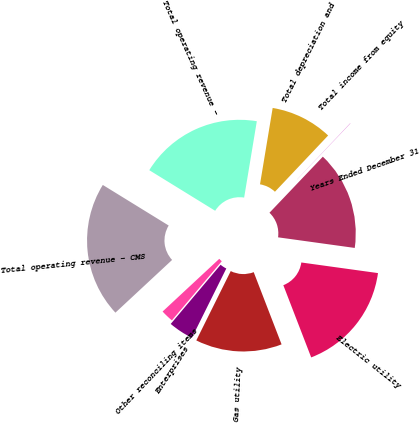Convert chart to OTSL. <chart><loc_0><loc_0><loc_500><loc_500><pie_chart><fcel>Years Ended December 31<fcel>Electric utility<fcel>Gas utility<fcel>Enterprises<fcel>Other reconciling items<fcel>Total operating revenue - CMS<fcel>Total operating revenue -<fcel>Total depreciation and<fcel>Total income from equity<nl><fcel>15.08%<fcel>16.95%<fcel>13.2%<fcel>3.81%<fcel>1.93%<fcel>20.71%<fcel>18.83%<fcel>9.44%<fcel>0.05%<nl></chart> 